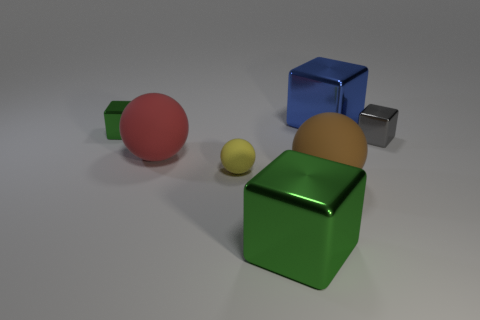Are there more tiny yellow balls than large spheres?
Offer a terse response. No. What material is the big brown ball?
Make the answer very short. Rubber. What number of big shiny things are in front of the large metallic cube behind the small green block?
Ensure brevity in your answer.  1. There is a small rubber sphere; is it the same color as the metallic thing in front of the tiny rubber ball?
Your answer should be very brief. No. The matte thing that is the same size as the brown matte ball is what color?
Make the answer very short. Red. Is there another big gray metal thing that has the same shape as the gray object?
Provide a succinct answer. No. Is the number of cubes less than the number of large blue cubes?
Make the answer very short. No. The small rubber object that is in front of the big red rubber object is what color?
Provide a short and direct response. Yellow. There is a green metal object to the right of the shiny object on the left side of the large green block; what is its shape?
Your answer should be compact. Cube. Is the large green thing made of the same material as the tiny cube that is to the right of the large brown thing?
Make the answer very short. Yes. 